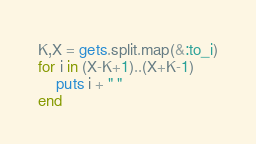Convert code to text. <code><loc_0><loc_0><loc_500><loc_500><_Ruby_>K,X = gets.split.map(&:to_i)
for i in (X-K+1)..(X+K-1)
    puts i + " "
end</code> 